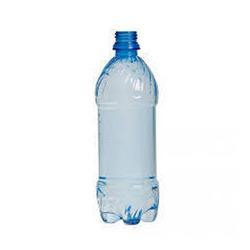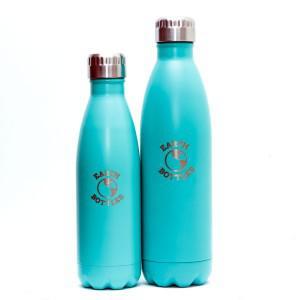The first image is the image on the left, the second image is the image on the right. Analyze the images presented: Is the assertion "One image shows at least one teal colored stainless steel water bottle with a silver chrome cap" valid? Answer yes or no. Yes. The first image is the image on the left, the second image is the image on the right. Considering the images on both sides, is "An image shows at least one opaque robin's-egg blue water bottle with a silver cap on it." valid? Answer yes or no. Yes. 